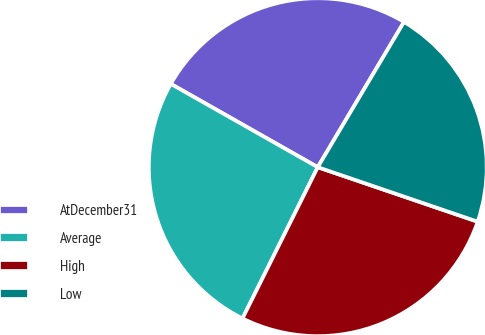Convert chart to OTSL. <chart><loc_0><loc_0><loc_500><loc_500><pie_chart><fcel>AtDecember31<fcel>Average<fcel>High<fcel>Low<nl><fcel>25.32%<fcel>25.86%<fcel>27.12%<fcel>21.7%<nl></chart> 